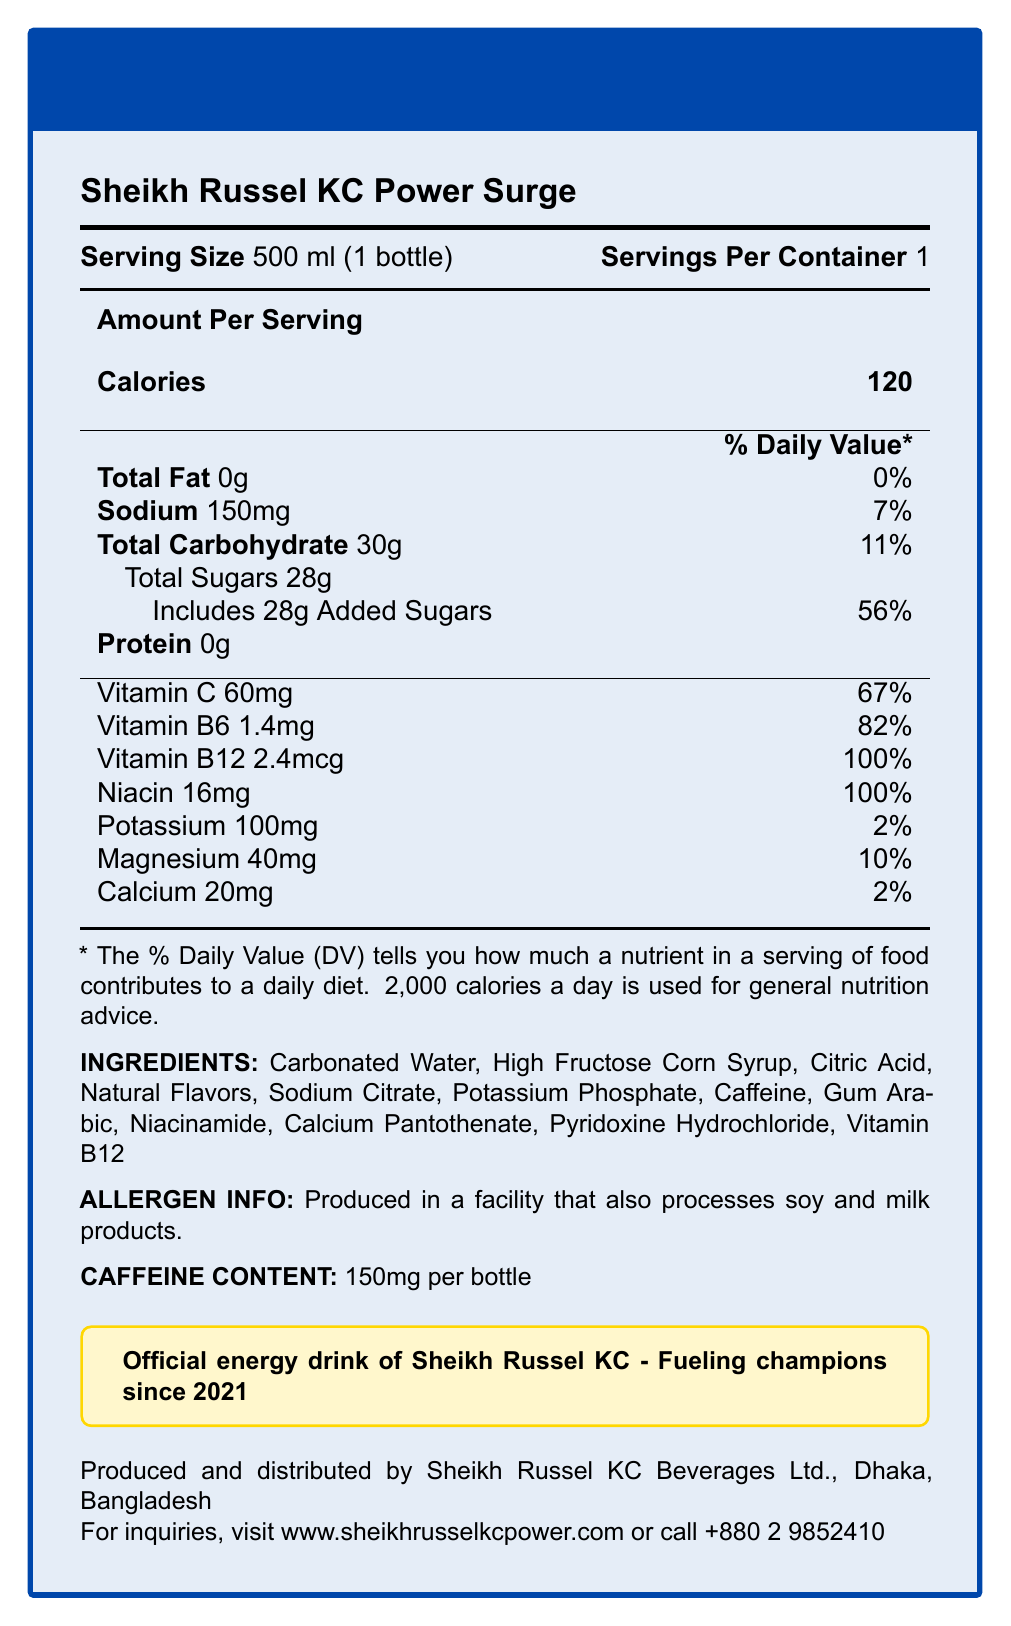what is the serving size for Sheikh Russel KC Power Surge? The serving size is explicitly mentioned as "500 ml (1 bottle)" on the Nutrition Facts Label.
Answer: 500 ml (1 bottle) how many calories are in a serving? The number of calories per serving is shown as "Calories 120".
Answer: 120 what is the amount of added sugars in the energy drink? Under Total Sugars, it's stated that it includes 28g Added Sugars.
Answer: 28g how much sodium does one serving contain? The amount of Sodium per serving is listed as "150mg" with a daily value of 7%.
Answer: 150mg what is the daily value percentage for vitamin C? The daily value percentage for Vitamin C is given as 67%.
Answer: 67% what is the main ingredient in the energy drink? The first ingredient listed is Carbonated Water, which typically indicates it is the main ingredient by volume.
Answer: Carbonated Water how much caffeine is there per bottle? A. 100mg B. 150mg C. 200mg The caffeine content per bottle is listed as 150mg.
Answer: B which vitamin has the highest daily value percentage? A. Vitamin C B. Vitamin B6 C. Vitamin B12 D. Niacin Vitamin B12 has the highest daily value percentage at 100%.
Answer: C is the energy drink suitable for people with soy allergies? The allergen information states that the product is produced in a facility that processes soy and milk products.
Answer: No describe the main purpose of the Nutrition Facts Label for Sheikh Russel KC Power Surge The document gives a concise breakdown of the nutrition information such as calories, total fat, sodium, carbohydrates, sugars, and proteins per serving. It also details the vitamins and minerals present along with their daily values. Additionally, the label covers ingredients, allergen info, caffeine content, and contact information related to the manufacturer.
Answer: The purpose of the Nutrition Facts Label is to provide detailed information on the nutritional content, ingredients, and other relevant data about the energy drink named Sheikh Russel KC Power Surge, including serving size, calories, key vitamins, and minerals, as well as allergen information and manufacturer details. what is the percentage of the daily value for carbohydrates per serving? The total carbohydrate content is 30g, which is noted to be 11% of the daily value.
Answer: 11% is there any protein in the energy drink? The protein content is stated as "0g", indicating there is no protein in the energy drink.
Answer: No what is the total sugar content of the drink, including added sugars? The total sugars content is 28g, which includes added sugars.
Answer: 28g who manufactures Sheikh Russel KC Power Surge? The manufacturer is listed as Sheikh Russel KC Beverages Ltd., Dhaka, Bangladesh.
Answer: Sheikh Russel KC Beverages Ltd. what are the additional sources of electrolytes in the drink? The electrolytes in the drink are listed as Potassium (100mg), Magnesium (40mg), and Calcium (20mg), along with their respective daily values.
Answer: Potassium, Magnesium, Calcium how much Vitamin B12 is in a serving? The amount of Vitamin B12 per serving is noted as 2.4mcg, which is 100% of the daily value.
Answer: 2.4mcg provide the brand statement of the energy drink The brand statement is indicated at the bottom in a highlighted box.
Answer: Official energy drink of Sheikh Russel KC - Fueling champions since 2021 where can you find more information or make inquiries about the drink? The contact details for inquiries are provided at the end of the document.
Answer: www.sheikhrusselkcpower.com or call +880 2 9852410 what is the daily value percentage contribution of magnesium per serving? The magnesium content is 40mg, which contributes to 10% of the daily value.
Answer: 10% what kind of flavors are used in the energy drink? The ingredient list includes Natural Flavors.
Answer: Natural Flavors what year was Sheikh Russel KC Power Surge established as the official energy drink? The brand statement mentions that it's been fueling champions since 2021.
Answer: 2021 what is the country of origin for Sheikh Russel KC Power Surge? The product is produced and distributed in Dhaka, Bangladesh.
Answer: Bangladesh is the exact formulation process detailed on the label? The label does not provide detailed information about the formulation process.
Answer: Not enough information 